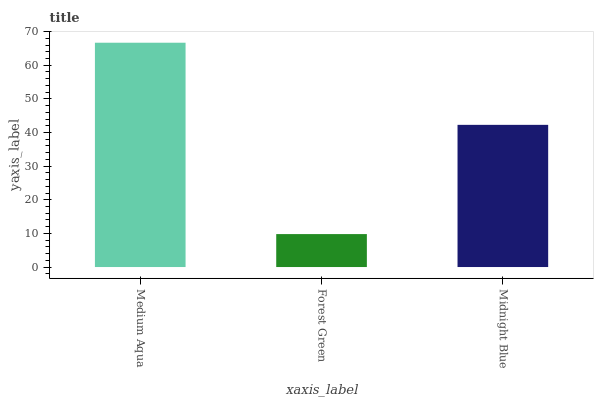Is Forest Green the minimum?
Answer yes or no. Yes. Is Medium Aqua the maximum?
Answer yes or no. Yes. Is Midnight Blue the minimum?
Answer yes or no. No. Is Midnight Blue the maximum?
Answer yes or no. No. Is Midnight Blue greater than Forest Green?
Answer yes or no. Yes. Is Forest Green less than Midnight Blue?
Answer yes or no. Yes. Is Forest Green greater than Midnight Blue?
Answer yes or no. No. Is Midnight Blue less than Forest Green?
Answer yes or no. No. Is Midnight Blue the high median?
Answer yes or no. Yes. Is Midnight Blue the low median?
Answer yes or no. Yes. Is Forest Green the high median?
Answer yes or no. No. Is Medium Aqua the low median?
Answer yes or no. No. 